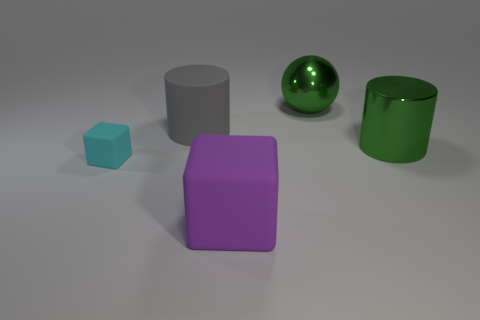There is a cube to the right of the rubber thing behind the matte block that is behind the big rubber cube; what is its material?
Offer a very short reply. Rubber. What material is the large cylinder that is the same color as the sphere?
Your answer should be very brief. Metal. What number of gray objects have the same material as the big ball?
Your answer should be very brief. 0. Is the size of the rubber block in front of the cyan thing the same as the large shiny sphere?
Offer a terse response. Yes. What color is the big cylinder that is the same material as the small thing?
Your answer should be compact. Gray. Is there anything else that is the same size as the cyan rubber block?
Keep it short and to the point. No. What number of cyan rubber cubes are on the left side of the cyan thing?
Your response must be concise. 0. Is the color of the rubber block behind the purple rubber object the same as the large cylinder right of the big purple rubber cube?
Make the answer very short. No. The other thing that is the same shape as the small cyan object is what color?
Your response must be concise. Purple. Is there anything else that is the same shape as the purple matte thing?
Your answer should be very brief. Yes. 